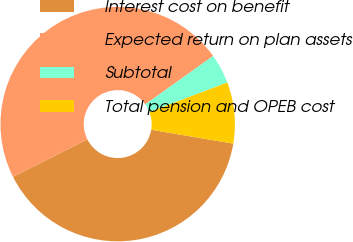<chart> <loc_0><loc_0><loc_500><loc_500><pie_chart><fcel>Interest cost on benefit<fcel>Expected return on plan assets<fcel>Subtotal<fcel>Total pension and OPEB cost<nl><fcel>39.9%<fcel>47.57%<fcel>4.09%<fcel>8.44%<nl></chart> 